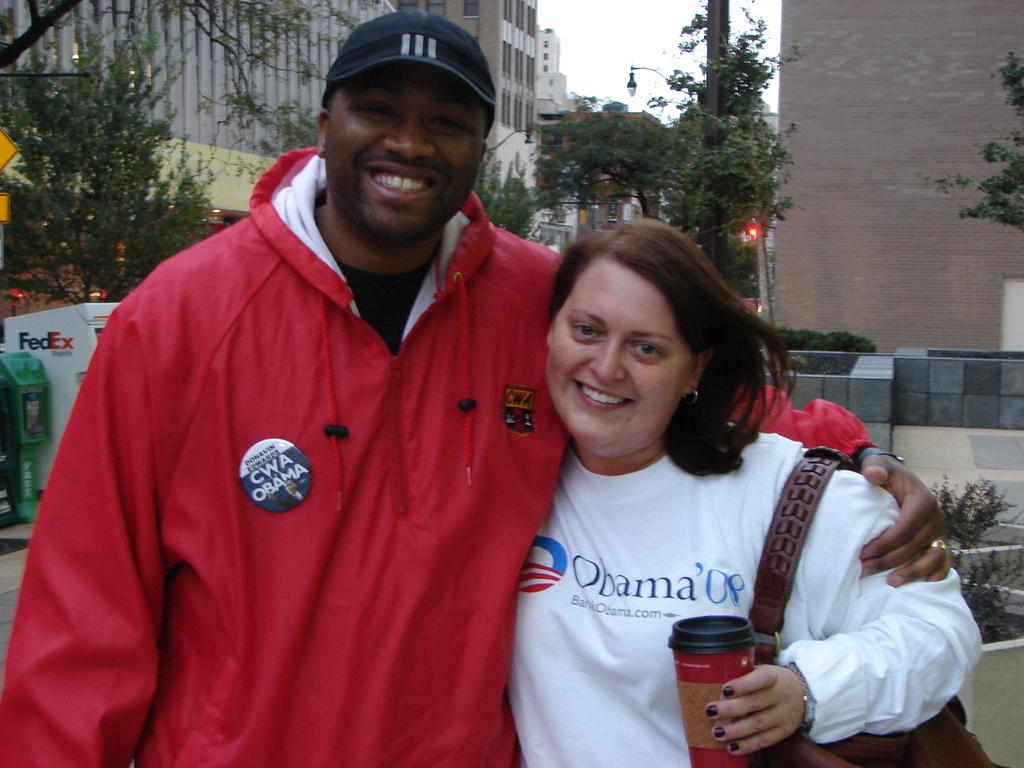<image>
Describe the image concisely. A man and a woman posing together, both wearing shirts/badges supporting Obama. 